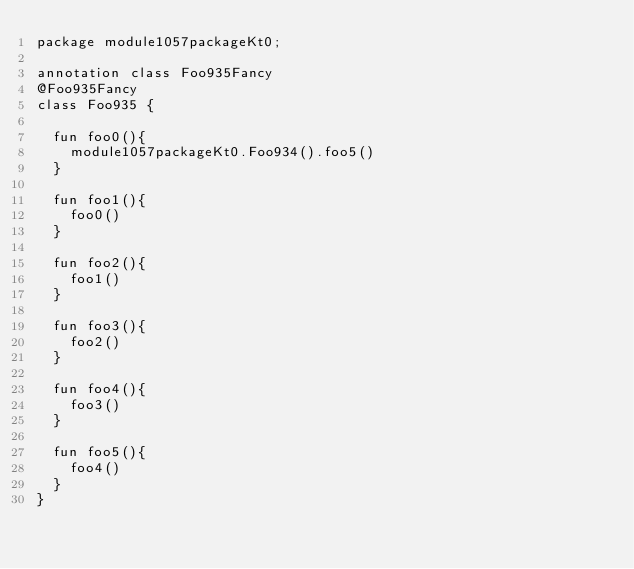Convert code to text. <code><loc_0><loc_0><loc_500><loc_500><_Kotlin_>package module1057packageKt0;

annotation class Foo935Fancy
@Foo935Fancy
class Foo935 {

  fun foo0(){
    module1057packageKt0.Foo934().foo5()
  }

  fun foo1(){
    foo0()
  }

  fun foo2(){
    foo1()
  }

  fun foo3(){
    foo2()
  }

  fun foo4(){
    foo3()
  }

  fun foo5(){
    foo4()
  }
}</code> 